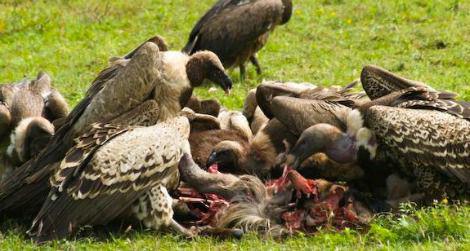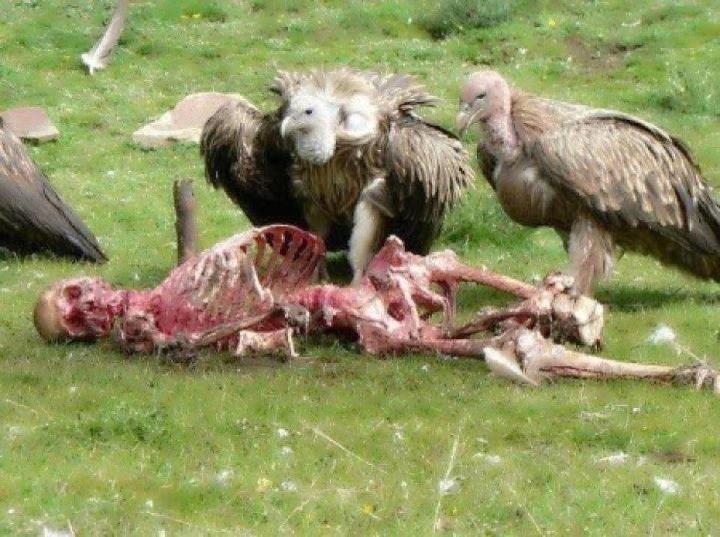The first image is the image on the left, the second image is the image on the right. Analyze the images presented: Is the assertion "At least one of the images only has one bird standing on a dead animal." valid? Answer yes or no. No. The first image is the image on the left, the second image is the image on the right. Analyze the images presented: Is the assertion "In one of the images, a lone bird is seen at the body of a dead animal." valid? Answer yes or no. No. 